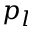Convert formula to latex. <formula><loc_0><loc_0><loc_500><loc_500>p _ { l }</formula> 